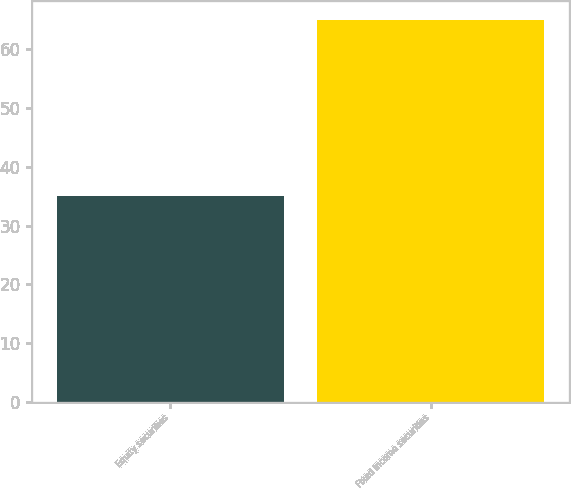<chart> <loc_0><loc_0><loc_500><loc_500><bar_chart><fcel>Equity securities<fcel>Fixed income securities<nl><fcel>35<fcel>65<nl></chart> 